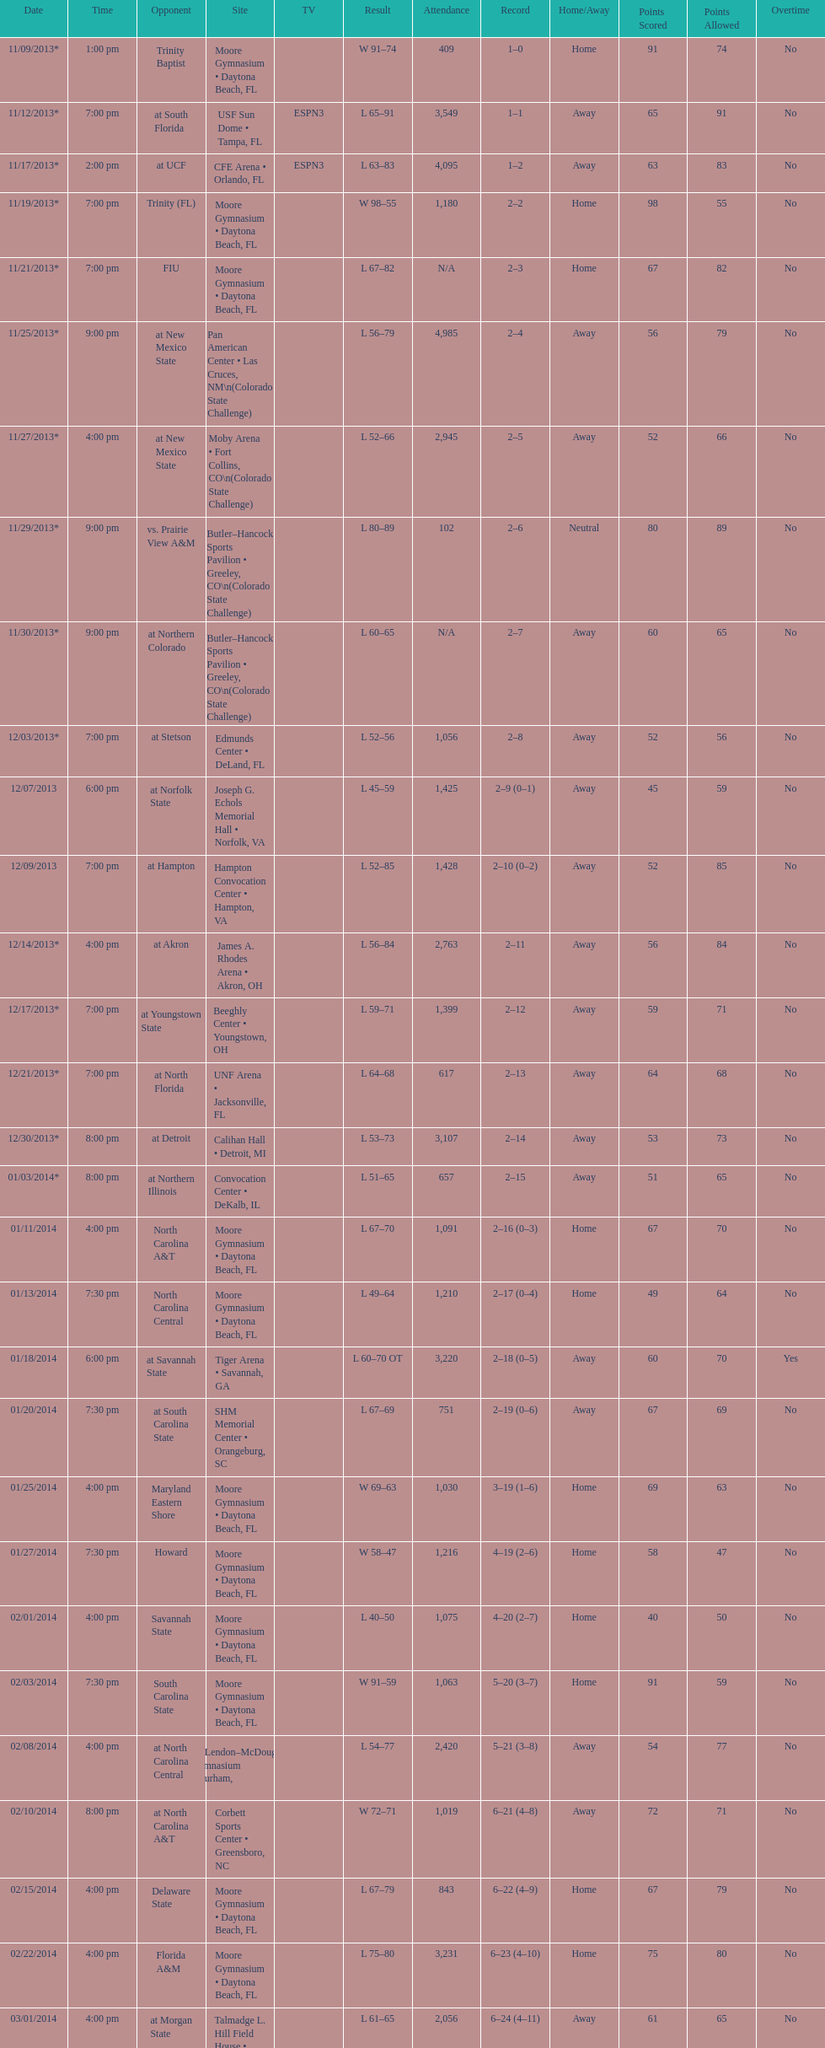How much larger was the attendance on 11/25/2013 than 12/21/2013? 4368. 